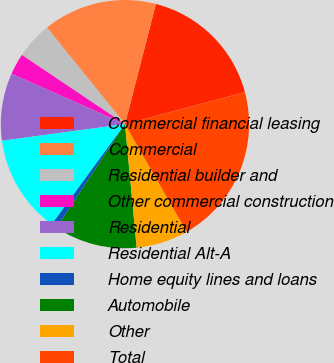Convert chart to OTSL. <chart><loc_0><loc_0><loc_500><loc_500><pie_chart><fcel>Commercial financial leasing<fcel>Commercial<fcel>Residential builder and<fcel>Other commercial construction<fcel>Residential<fcel>Residential Alt-A<fcel>Home equity lines and loans<fcel>Automobile<fcel>Other<fcel>Total<nl><fcel>16.84%<fcel>14.83%<fcel>4.77%<fcel>2.76%<fcel>8.79%<fcel>12.82%<fcel>0.75%<fcel>10.8%<fcel>6.78%<fcel>20.86%<nl></chart> 